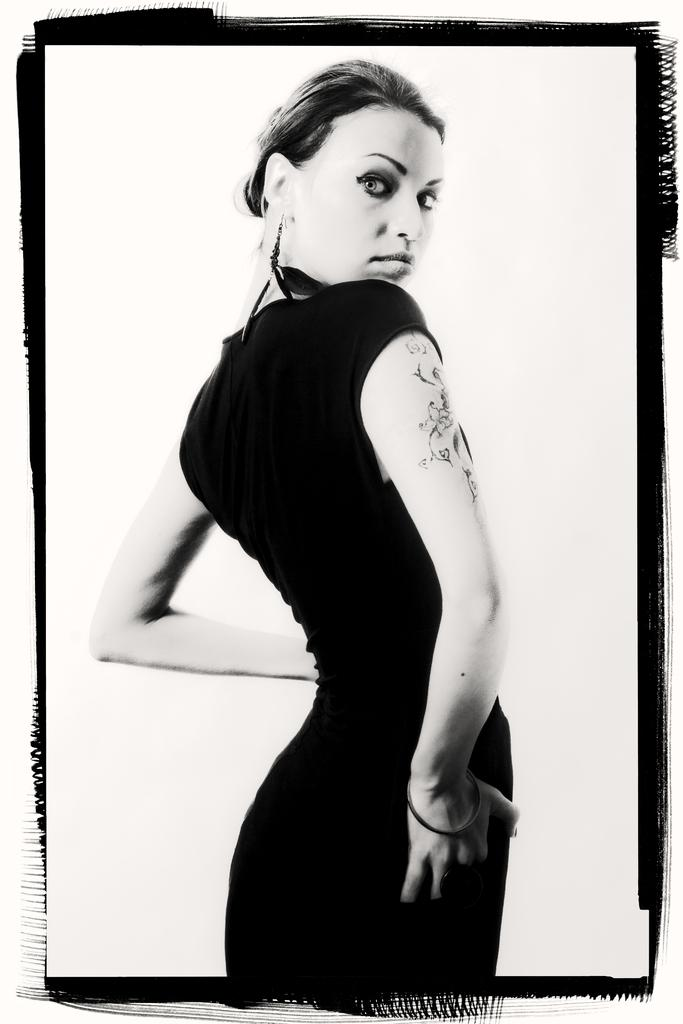Who is the main subject in the image? There is a woman in the image. What distinguishing feature can be seen on the woman's hand? The woman has a tattoo on her hand. What color is the background of the image? The background of the image is white. What type of apparel is the woman wearing on her toe in the image? There is no mention of the woman wearing any apparel on her toe in the image. 